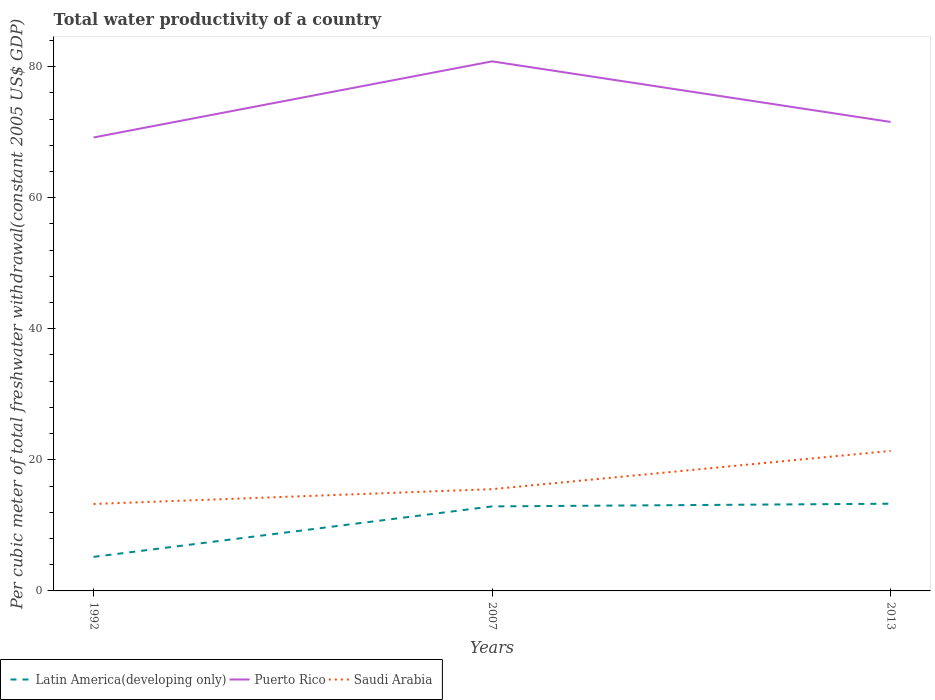How many different coloured lines are there?
Offer a very short reply. 3. Does the line corresponding to Puerto Rico intersect with the line corresponding to Saudi Arabia?
Your answer should be compact. No. Is the number of lines equal to the number of legend labels?
Your answer should be compact. Yes. Across all years, what is the maximum total water productivity in Latin America(developing only)?
Provide a short and direct response. 5.19. In which year was the total water productivity in Puerto Rico maximum?
Make the answer very short. 1992. What is the total total water productivity in Puerto Rico in the graph?
Your answer should be compact. 9.25. What is the difference between the highest and the second highest total water productivity in Latin America(developing only)?
Offer a terse response. 8.11. What is the difference between the highest and the lowest total water productivity in Latin America(developing only)?
Your answer should be very brief. 2. How many lines are there?
Your response must be concise. 3. How many years are there in the graph?
Offer a terse response. 3. What is the difference between two consecutive major ticks on the Y-axis?
Provide a succinct answer. 20. Are the values on the major ticks of Y-axis written in scientific E-notation?
Provide a short and direct response. No. Does the graph contain grids?
Ensure brevity in your answer.  No. What is the title of the graph?
Your answer should be very brief. Total water productivity of a country. Does "Timor-Leste" appear as one of the legend labels in the graph?
Give a very brief answer. No. What is the label or title of the X-axis?
Ensure brevity in your answer.  Years. What is the label or title of the Y-axis?
Provide a short and direct response. Per cubic meter of total freshwater withdrawal(constant 2005 US$ GDP). What is the Per cubic meter of total freshwater withdrawal(constant 2005 US$ GDP) in Latin America(developing only) in 1992?
Offer a very short reply. 5.19. What is the Per cubic meter of total freshwater withdrawal(constant 2005 US$ GDP) of Puerto Rico in 1992?
Your answer should be very brief. 69.19. What is the Per cubic meter of total freshwater withdrawal(constant 2005 US$ GDP) in Saudi Arabia in 1992?
Your answer should be very brief. 13.27. What is the Per cubic meter of total freshwater withdrawal(constant 2005 US$ GDP) of Latin America(developing only) in 2007?
Offer a terse response. 12.9. What is the Per cubic meter of total freshwater withdrawal(constant 2005 US$ GDP) of Puerto Rico in 2007?
Your answer should be compact. 80.81. What is the Per cubic meter of total freshwater withdrawal(constant 2005 US$ GDP) of Saudi Arabia in 2007?
Provide a succinct answer. 15.53. What is the Per cubic meter of total freshwater withdrawal(constant 2005 US$ GDP) in Latin America(developing only) in 2013?
Your answer should be compact. 13.31. What is the Per cubic meter of total freshwater withdrawal(constant 2005 US$ GDP) in Puerto Rico in 2013?
Make the answer very short. 71.56. What is the Per cubic meter of total freshwater withdrawal(constant 2005 US$ GDP) of Saudi Arabia in 2013?
Offer a very short reply. 21.37. Across all years, what is the maximum Per cubic meter of total freshwater withdrawal(constant 2005 US$ GDP) of Latin America(developing only)?
Provide a succinct answer. 13.31. Across all years, what is the maximum Per cubic meter of total freshwater withdrawal(constant 2005 US$ GDP) of Puerto Rico?
Offer a terse response. 80.81. Across all years, what is the maximum Per cubic meter of total freshwater withdrawal(constant 2005 US$ GDP) in Saudi Arabia?
Offer a very short reply. 21.37. Across all years, what is the minimum Per cubic meter of total freshwater withdrawal(constant 2005 US$ GDP) in Latin America(developing only)?
Provide a short and direct response. 5.19. Across all years, what is the minimum Per cubic meter of total freshwater withdrawal(constant 2005 US$ GDP) of Puerto Rico?
Your response must be concise. 69.19. Across all years, what is the minimum Per cubic meter of total freshwater withdrawal(constant 2005 US$ GDP) in Saudi Arabia?
Ensure brevity in your answer.  13.27. What is the total Per cubic meter of total freshwater withdrawal(constant 2005 US$ GDP) in Latin America(developing only) in the graph?
Your answer should be compact. 31.4. What is the total Per cubic meter of total freshwater withdrawal(constant 2005 US$ GDP) in Puerto Rico in the graph?
Your answer should be very brief. 221.56. What is the total Per cubic meter of total freshwater withdrawal(constant 2005 US$ GDP) in Saudi Arabia in the graph?
Make the answer very short. 50.16. What is the difference between the Per cubic meter of total freshwater withdrawal(constant 2005 US$ GDP) of Latin America(developing only) in 1992 and that in 2007?
Make the answer very short. -7.7. What is the difference between the Per cubic meter of total freshwater withdrawal(constant 2005 US$ GDP) in Puerto Rico in 1992 and that in 2007?
Your answer should be very brief. -11.62. What is the difference between the Per cubic meter of total freshwater withdrawal(constant 2005 US$ GDP) in Saudi Arabia in 1992 and that in 2007?
Ensure brevity in your answer.  -2.26. What is the difference between the Per cubic meter of total freshwater withdrawal(constant 2005 US$ GDP) in Latin America(developing only) in 1992 and that in 2013?
Provide a succinct answer. -8.11. What is the difference between the Per cubic meter of total freshwater withdrawal(constant 2005 US$ GDP) in Puerto Rico in 1992 and that in 2013?
Provide a short and direct response. -2.37. What is the difference between the Per cubic meter of total freshwater withdrawal(constant 2005 US$ GDP) of Saudi Arabia in 1992 and that in 2013?
Make the answer very short. -8.1. What is the difference between the Per cubic meter of total freshwater withdrawal(constant 2005 US$ GDP) of Latin America(developing only) in 2007 and that in 2013?
Your response must be concise. -0.41. What is the difference between the Per cubic meter of total freshwater withdrawal(constant 2005 US$ GDP) of Puerto Rico in 2007 and that in 2013?
Your answer should be compact. 9.25. What is the difference between the Per cubic meter of total freshwater withdrawal(constant 2005 US$ GDP) in Saudi Arabia in 2007 and that in 2013?
Your answer should be very brief. -5.84. What is the difference between the Per cubic meter of total freshwater withdrawal(constant 2005 US$ GDP) in Latin America(developing only) in 1992 and the Per cubic meter of total freshwater withdrawal(constant 2005 US$ GDP) in Puerto Rico in 2007?
Offer a very short reply. -75.61. What is the difference between the Per cubic meter of total freshwater withdrawal(constant 2005 US$ GDP) of Latin America(developing only) in 1992 and the Per cubic meter of total freshwater withdrawal(constant 2005 US$ GDP) of Saudi Arabia in 2007?
Keep it short and to the point. -10.33. What is the difference between the Per cubic meter of total freshwater withdrawal(constant 2005 US$ GDP) of Puerto Rico in 1992 and the Per cubic meter of total freshwater withdrawal(constant 2005 US$ GDP) of Saudi Arabia in 2007?
Keep it short and to the point. 53.66. What is the difference between the Per cubic meter of total freshwater withdrawal(constant 2005 US$ GDP) of Latin America(developing only) in 1992 and the Per cubic meter of total freshwater withdrawal(constant 2005 US$ GDP) of Puerto Rico in 2013?
Give a very brief answer. -66.37. What is the difference between the Per cubic meter of total freshwater withdrawal(constant 2005 US$ GDP) of Latin America(developing only) in 1992 and the Per cubic meter of total freshwater withdrawal(constant 2005 US$ GDP) of Saudi Arabia in 2013?
Provide a succinct answer. -16.17. What is the difference between the Per cubic meter of total freshwater withdrawal(constant 2005 US$ GDP) in Puerto Rico in 1992 and the Per cubic meter of total freshwater withdrawal(constant 2005 US$ GDP) in Saudi Arabia in 2013?
Your response must be concise. 47.82. What is the difference between the Per cubic meter of total freshwater withdrawal(constant 2005 US$ GDP) of Latin America(developing only) in 2007 and the Per cubic meter of total freshwater withdrawal(constant 2005 US$ GDP) of Puerto Rico in 2013?
Keep it short and to the point. -58.66. What is the difference between the Per cubic meter of total freshwater withdrawal(constant 2005 US$ GDP) in Latin America(developing only) in 2007 and the Per cubic meter of total freshwater withdrawal(constant 2005 US$ GDP) in Saudi Arabia in 2013?
Give a very brief answer. -8.47. What is the difference between the Per cubic meter of total freshwater withdrawal(constant 2005 US$ GDP) in Puerto Rico in 2007 and the Per cubic meter of total freshwater withdrawal(constant 2005 US$ GDP) in Saudi Arabia in 2013?
Keep it short and to the point. 59.44. What is the average Per cubic meter of total freshwater withdrawal(constant 2005 US$ GDP) of Latin America(developing only) per year?
Your answer should be compact. 10.47. What is the average Per cubic meter of total freshwater withdrawal(constant 2005 US$ GDP) of Puerto Rico per year?
Keep it short and to the point. 73.85. What is the average Per cubic meter of total freshwater withdrawal(constant 2005 US$ GDP) in Saudi Arabia per year?
Make the answer very short. 16.72. In the year 1992, what is the difference between the Per cubic meter of total freshwater withdrawal(constant 2005 US$ GDP) in Latin America(developing only) and Per cubic meter of total freshwater withdrawal(constant 2005 US$ GDP) in Puerto Rico?
Offer a terse response. -63.99. In the year 1992, what is the difference between the Per cubic meter of total freshwater withdrawal(constant 2005 US$ GDP) in Latin America(developing only) and Per cubic meter of total freshwater withdrawal(constant 2005 US$ GDP) in Saudi Arabia?
Your response must be concise. -8.07. In the year 1992, what is the difference between the Per cubic meter of total freshwater withdrawal(constant 2005 US$ GDP) in Puerto Rico and Per cubic meter of total freshwater withdrawal(constant 2005 US$ GDP) in Saudi Arabia?
Keep it short and to the point. 55.92. In the year 2007, what is the difference between the Per cubic meter of total freshwater withdrawal(constant 2005 US$ GDP) of Latin America(developing only) and Per cubic meter of total freshwater withdrawal(constant 2005 US$ GDP) of Puerto Rico?
Provide a short and direct response. -67.91. In the year 2007, what is the difference between the Per cubic meter of total freshwater withdrawal(constant 2005 US$ GDP) in Latin America(developing only) and Per cubic meter of total freshwater withdrawal(constant 2005 US$ GDP) in Saudi Arabia?
Make the answer very short. -2.63. In the year 2007, what is the difference between the Per cubic meter of total freshwater withdrawal(constant 2005 US$ GDP) in Puerto Rico and Per cubic meter of total freshwater withdrawal(constant 2005 US$ GDP) in Saudi Arabia?
Offer a very short reply. 65.28. In the year 2013, what is the difference between the Per cubic meter of total freshwater withdrawal(constant 2005 US$ GDP) of Latin America(developing only) and Per cubic meter of total freshwater withdrawal(constant 2005 US$ GDP) of Puerto Rico?
Your answer should be compact. -58.25. In the year 2013, what is the difference between the Per cubic meter of total freshwater withdrawal(constant 2005 US$ GDP) in Latin America(developing only) and Per cubic meter of total freshwater withdrawal(constant 2005 US$ GDP) in Saudi Arabia?
Provide a short and direct response. -8.06. In the year 2013, what is the difference between the Per cubic meter of total freshwater withdrawal(constant 2005 US$ GDP) of Puerto Rico and Per cubic meter of total freshwater withdrawal(constant 2005 US$ GDP) of Saudi Arabia?
Offer a very short reply. 50.19. What is the ratio of the Per cubic meter of total freshwater withdrawal(constant 2005 US$ GDP) of Latin America(developing only) in 1992 to that in 2007?
Make the answer very short. 0.4. What is the ratio of the Per cubic meter of total freshwater withdrawal(constant 2005 US$ GDP) of Puerto Rico in 1992 to that in 2007?
Provide a succinct answer. 0.86. What is the ratio of the Per cubic meter of total freshwater withdrawal(constant 2005 US$ GDP) of Saudi Arabia in 1992 to that in 2007?
Ensure brevity in your answer.  0.85. What is the ratio of the Per cubic meter of total freshwater withdrawal(constant 2005 US$ GDP) of Latin America(developing only) in 1992 to that in 2013?
Give a very brief answer. 0.39. What is the ratio of the Per cubic meter of total freshwater withdrawal(constant 2005 US$ GDP) of Puerto Rico in 1992 to that in 2013?
Offer a very short reply. 0.97. What is the ratio of the Per cubic meter of total freshwater withdrawal(constant 2005 US$ GDP) in Saudi Arabia in 1992 to that in 2013?
Provide a short and direct response. 0.62. What is the ratio of the Per cubic meter of total freshwater withdrawal(constant 2005 US$ GDP) in Latin America(developing only) in 2007 to that in 2013?
Provide a succinct answer. 0.97. What is the ratio of the Per cubic meter of total freshwater withdrawal(constant 2005 US$ GDP) of Puerto Rico in 2007 to that in 2013?
Your answer should be compact. 1.13. What is the ratio of the Per cubic meter of total freshwater withdrawal(constant 2005 US$ GDP) in Saudi Arabia in 2007 to that in 2013?
Your answer should be very brief. 0.73. What is the difference between the highest and the second highest Per cubic meter of total freshwater withdrawal(constant 2005 US$ GDP) of Latin America(developing only)?
Your answer should be very brief. 0.41. What is the difference between the highest and the second highest Per cubic meter of total freshwater withdrawal(constant 2005 US$ GDP) of Puerto Rico?
Your answer should be compact. 9.25. What is the difference between the highest and the second highest Per cubic meter of total freshwater withdrawal(constant 2005 US$ GDP) in Saudi Arabia?
Offer a very short reply. 5.84. What is the difference between the highest and the lowest Per cubic meter of total freshwater withdrawal(constant 2005 US$ GDP) in Latin America(developing only)?
Offer a very short reply. 8.11. What is the difference between the highest and the lowest Per cubic meter of total freshwater withdrawal(constant 2005 US$ GDP) in Puerto Rico?
Ensure brevity in your answer.  11.62. What is the difference between the highest and the lowest Per cubic meter of total freshwater withdrawal(constant 2005 US$ GDP) of Saudi Arabia?
Give a very brief answer. 8.1. 